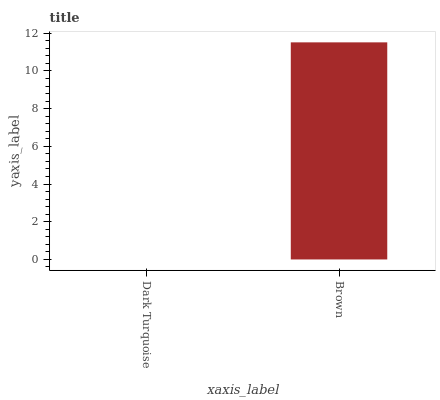Is Dark Turquoise the minimum?
Answer yes or no. Yes. Is Brown the maximum?
Answer yes or no. Yes. Is Brown the minimum?
Answer yes or no. No. Is Brown greater than Dark Turquoise?
Answer yes or no. Yes. Is Dark Turquoise less than Brown?
Answer yes or no. Yes. Is Dark Turquoise greater than Brown?
Answer yes or no. No. Is Brown less than Dark Turquoise?
Answer yes or no. No. Is Brown the high median?
Answer yes or no. Yes. Is Dark Turquoise the low median?
Answer yes or no. Yes. Is Dark Turquoise the high median?
Answer yes or no. No. Is Brown the low median?
Answer yes or no. No. 